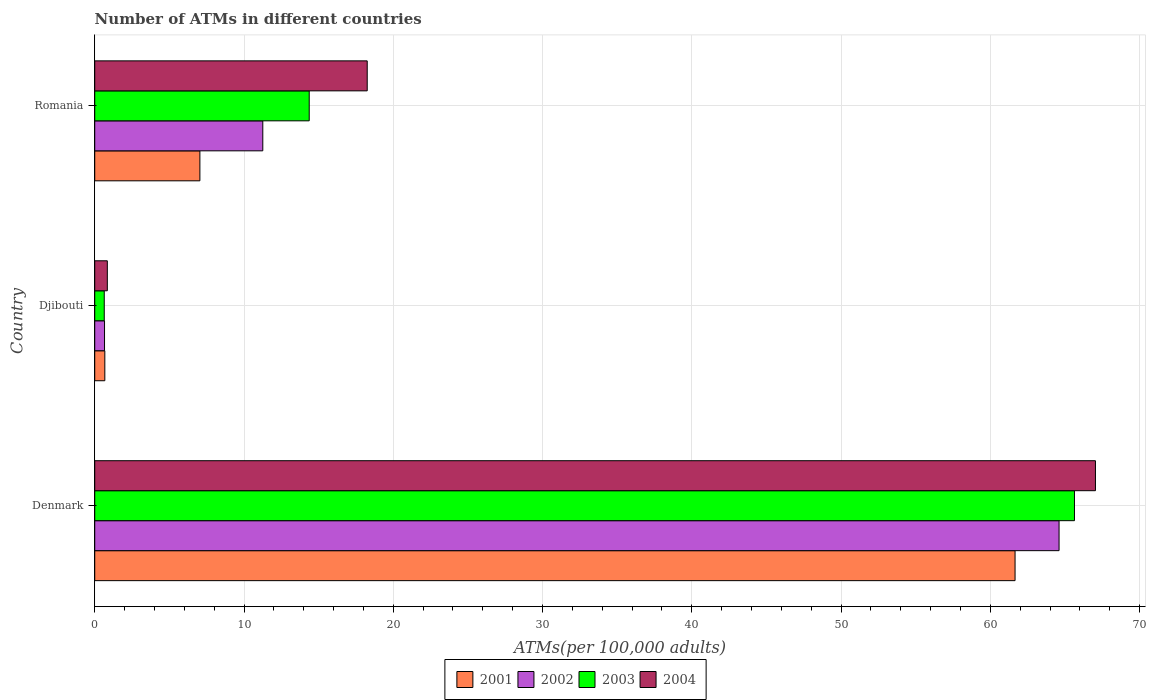How many bars are there on the 3rd tick from the top?
Your answer should be compact. 4. How many bars are there on the 3rd tick from the bottom?
Your response must be concise. 4. What is the label of the 3rd group of bars from the top?
Provide a short and direct response. Denmark. In how many cases, is the number of bars for a given country not equal to the number of legend labels?
Ensure brevity in your answer.  0. What is the number of ATMs in 2001 in Romania?
Your response must be concise. 7.04. Across all countries, what is the maximum number of ATMs in 2004?
Provide a succinct answer. 67.04. Across all countries, what is the minimum number of ATMs in 2001?
Provide a succinct answer. 0.68. In which country was the number of ATMs in 2002 maximum?
Your answer should be very brief. Denmark. In which country was the number of ATMs in 2002 minimum?
Keep it short and to the point. Djibouti. What is the total number of ATMs in 2003 in the graph?
Provide a short and direct response. 80.65. What is the difference between the number of ATMs in 2004 in Denmark and that in Romania?
Give a very brief answer. 48.79. What is the difference between the number of ATMs in 2003 in Denmark and the number of ATMs in 2001 in Djibouti?
Your answer should be very brief. 64.96. What is the average number of ATMs in 2003 per country?
Your answer should be very brief. 26.88. What is the difference between the number of ATMs in 2002 and number of ATMs in 2001 in Romania?
Provide a succinct answer. 4.21. What is the ratio of the number of ATMs in 2003 in Denmark to that in Djibouti?
Ensure brevity in your answer.  102.88. Is the number of ATMs in 2002 in Denmark less than that in Romania?
Your answer should be compact. No. What is the difference between the highest and the second highest number of ATMs in 2003?
Offer a very short reply. 51.27. What is the difference between the highest and the lowest number of ATMs in 2001?
Your response must be concise. 60.98. In how many countries, is the number of ATMs in 2004 greater than the average number of ATMs in 2004 taken over all countries?
Make the answer very short. 1. Is it the case that in every country, the sum of the number of ATMs in 2004 and number of ATMs in 2003 is greater than the sum of number of ATMs in 2002 and number of ATMs in 2001?
Keep it short and to the point. No. What does the 4th bar from the bottom in Denmark represents?
Give a very brief answer. 2004. Are all the bars in the graph horizontal?
Your answer should be compact. Yes. Does the graph contain grids?
Offer a terse response. Yes. Where does the legend appear in the graph?
Your answer should be compact. Bottom center. How many legend labels are there?
Give a very brief answer. 4. What is the title of the graph?
Offer a very short reply. Number of ATMs in different countries. What is the label or title of the X-axis?
Ensure brevity in your answer.  ATMs(per 100,0 adults). What is the ATMs(per 100,000 adults) of 2001 in Denmark?
Make the answer very short. 61.66. What is the ATMs(per 100,000 adults) of 2002 in Denmark?
Offer a very short reply. 64.61. What is the ATMs(per 100,000 adults) of 2003 in Denmark?
Make the answer very short. 65.64. What is the ATMs(per 100,000 adults) of 2004 in Denmark?
Make the answer very short. 67.04. What is the ATMs(per 100,000 adults) of 2001 in Djibouti?
Ensure brevity in your answer.  0.68. What is the ATMs(per 100,000 adults) in 2002 in Djibouti?
Keep it short and to the point. 0.66. What is the ATMs(per 100,000 adults) in 2003 in Djibouti?
Your answer should be compact. 0.64. What is the ATMs(per 100,000 adults) in 2004 in Djibouti?
Your answer should be very brief. 0.84. What is the ATMs(per 100,000 adults) of 2001 in Romania?
Provide a succinct answer. 7.04. What is the ATMs(per 100,000 adults) in 2002 in Romania?
Give a very brief answer. 11.26. What is the ATMs(per 100,000 adults) of 2003 in Romania?
Offer a very short reply. 14.37. What is the ATMs(per 100,000 adults) in 2004 in Romania?
Provide a short and direct response. 18.26. Across all countries, what is the maximum ATMs(per 100,000 adults) in 2001?
Offer a terse response. 61.66. Across all countries, what is the maximum ATMs(per 100,000 adults) of 2002?
Provide a succinct answer. 64.61. Across all countries, what is the maximum ATMs(per 100,000 adults) of 2003?
Keep it short and to the point. 65.64. Across all countries, what is the maximum ATMs(per 100,000 adults) in 2004?
Provide a succinct answer. 67.04. Across all countries, what is the minimum ATMs(per 100,000 adults) in 2001?
Make the answer very short. 0.68. Across all countries, what is the minimum ATMs(per 100,000 adults) of 2002?
Your answer should be very brief. 0.66. Across all countries, what is the minimum ATMs(per 100,000 adults) in 2003?
Provide a succinct answer. 0.64. Across all countries, what is the minimum ATMs(per 100,000 adults) in 2004?
Your answer should be compact. 0.84. What is the total ATMs(per 100,000 adults) of 2001 in the graph?
Your answer should be very brief. 69.38. What is the total ATMs(per 100,000 adults) in 2002 in the graph?
Make the answer very short. 76.52. What is the total ATMs(per 100,000 adults) in 2003 in the graph?
Your answer should be compact. 80.65. What is the total ATMs(per 100,000 adults) in 2004 in the graph?
Keep it short and to the point. 86.14. What is the difference between the ATMs(per 100,000 adults) in 2001 in Denmark and that in Djibouti?
Make the answer very short. 60.98. What is the difference between the ATMs(per 100,000 adults) in 2002 in Denmark and that in Djibouti?
Offer a terse response. 63.95. What is the difference between the ATMs(per 100,000 adults) in 2003 in Denmark and that in Djibouti?
Your answer should be compact. 65. What is the difference between the ATMs(per 100,000 adults) of 2004 in Denmark and that in Djibouti?
Provide a succinct answer. 66.2. What is the difference between the ATMs(per 100,000 adults) of 2001 in Denmark and that in Romania?
Ensure brevity in your answer.  54.61. What is the difference between the ATMs(per 100,000 adults) in 2002 in Denmark and that in Romania?
Your answer should be very brief. 53.35. What is the difference between the ATMs(per 100,000 adults) of 2003 in Denmark and that in Romania?
Provide a succinct answer. 51.27. What is the difference between the ATMs(per 100,000 adults) in 2004 in Denmark and that in Romania?
Ensure brevity in your answer.  48.79. What is the difference between the ATMs(per 100,000 adults) in 2001 in Djibouti and that in Romania?
Ensure brevity in your answer.  -6.37. What is the difference between the ATMs(per 100,000 adults) in 2002 in Djibouti and that in Romania?
Your response must be concise. -10.6. What is the difference between the ATMs(per 100,000 adults) of 2003 in Djibouti and that in Romania?
Offer a very short reply. -13.73. What is the difference between the ATMs(per 100,000 adults) of 2004 in Djibouti and that in Romania?
Keep it short and to the point. -17.41. What is the difference between the ATMs(per 100,000 adults) of 2001 in Denmark and the ATMs(per 100,000 adults) of 2002 in Djibouti?
Ensure brevity in your answer.  61. What is the difference between the ATMs(per 100,000 adults) in 2001 in Denmark and the ATMs(per 100,000 adults) in 2003 in Djibouti?
Provide a succinct answer. 61.02. What is the difference between the ATMs(per 100,000 adults) in 2001 in Denmark and the ATMs(per 100,000 adults) in 2004 in Djibouti?
Offer a terse response. 60.81. What is the difference between the ATMs(per 100,000 adults) of 2002 in Denmark and the ATMs(per 100,000 adults) of 2003 in Djibouti?
Make the answer very short. 63.97. What is the difference between the ATMs(per 100,000 adults) of 2002 in Denmark and the ATMs(per 100,000 adults) of 2004 in Djibouti?
Your response must be concise. 63.76. What is the difference between the ATMs(per 100,000 adults) in 2003 in Denmark and the ATMs(per 100,000 adults) in 2004 in Djibouti?
Ensure brevity in your answer.  64.79. What is the difference between the ATMs(per 100,000 adults) in 2001 in Denmark and the ATMs(per 100,000 adults) in 2002 in Romania?
Your response must be concise. 50.4. What is the difference between the ATMs(per 100,000 adults) in 2001 in Denmark and the ATMs(per 100,000 adults) in 2003 in Romania?
Provide a short and direct response. 47.29. What is the difference between the ATMs(per 100,000 adults) in 2001 in Denmark and the ATMs(per 100,000 adults) in 2004 in Romania?
Ensure brevity in your answer.  43.4. What is the difference between the ATMs(per 100,000 adults) of 2002 in Denmark and the ATMs(per 100,000 adults) of 2003 in Romania?
Offer a terse response. 50.24. What is the difference between the ATMs(per 100,000 adults) in 2002 in Denmark and the ATMs(per 100,000 adults) in 2004 in Romania?
Keep it short and to the point. 46.35. What is the difference between the ATMs(per 100,000 adults) in 2003 in Denmark and the ATMs(per 100,000 adults) in 2004 in Romania?
Your response must be concise. 47.38. What is the difference between the ATMs(per 100,000 adults) of 2001 in Djibouti and the ATMs(per 100,000 adults) of 2002 in Romania?
Your answer should be very brief. -10.58. What is the difference between the ATMs(per 100,000 adults) in 2001 in Djibouti and the ATMs(per 100,000 adults) in 2003 in Romania?
Your answer should be very brief. -13.69. What is the difference between the ATMs(per 100,000 adults) of 2001 in Djibouti and the ATMs(per 100,000 adults) of 2004 in Romania?
Your response must be concise. -17.58. What is the difference between the ATMs(per 100,000 adults) in 2002 in Djibouti and the ATMs(per 100,000 adults) in 2003 in Romania?
Provide a succinct answer. -13.71. What is the difference between the ATMs(per 100,000 adults) of 2002 in Djibouti and the ATMs(per 100,000 adults) of 2004 in Romania?
Your answer should be very brief. -17.6. What is the difference between the ATMs(per 100,000 adults) in 2003 in Djibouti and the ATMs(per 100,000 adults) in 2004 in Romania?
Offer a very short reply. -17.62. What is the average ATMs(per 100,000 adults) in 2001 per country?
Your response must be concise. 23.13. What is the average ATMs(per 100,000 adults) of 2002 per country?
Offer a very short reply. 25.51. What is the average ATMs(per 100,000 adults) of 2003 per country?
Offer a very short reply. 26.88. What is the average ATMs(per 100,000 adults) of 2004 per country?
Your response must be concise. 28.71. What is the difference between the ATMs(per 100,000 adults) of 2001 and ATMs(per 100,000 adults) of 2002 in Denmark?
Your response must be concise. -2.95. What is the difference between the ATMs(per 100,000 adults) of 2001 and ATMs(per 100,000 adults) of 2003 in Denmark?
Your response must be concise. -3.98. What is the difference between the ATMs(per 100,000 adults) of 2001 and ATMs(per 100,000 adults) of 2004 in Denmark?
Offer a terse response. -5.39. What is the difference between the ATMs(per 100,000 adults) in 2002 and ATMs(per 100,000 adults) in 2003 in Denmark?
Give a very brief answer. -1.03. What is the difference between the ATMs(per 100,000 adults) in 2002 and ATMs(per 100,000 adults) in 2004 in Denmark?
Give a very brief answer. -2.44. What is the difference between the ATMs(per 100,000 adults) in 2003 and ATMs(per 100,000 adults) in 2004 in Denmark?
Your answer should be very brief. -1.41. What is the difference between the ATMs(per 100,000 adults) of 2001 and ATMs(per 100,000 adults) of 2002 in Djibouti?
Your answer should be compact. 0.02. What is the difference between the ATMs(per 100,000 adults) in 2001 and ATMs(per 100,000 adults) in 2003 in Djibouti?
Ensure brevity in your answer.  0.04. What is the difference between the ATMs(per 100,000 adults) of 2001 and ATMs(per 100,000 adults) of 2004 in Djibouti?
Provide a succinct answer. -0.17. What is the difference between the ATMs(per 100,000 adults) of 2002 and ATMs(per 100,000 adults) of 2003 in Djibouti?
Keep it short and to the point. 0.02. What is the difference between the ATMs(per 100,000 adults) of 2002 and ATMs(per 100,000 adults) of 2004 in Djibouti?
Make the answer very short. -0.19. What is the difference between the ATMs(per 100,000 adults) of 2003 and ATMs(per 100,000 adults) of 2004 in Djibouti?
Offer a very short reply. -0.21. What is the difference between the ATMs(per 100,000 adults) of 2001 and ATMs(per 100,000 adults) of 2002 in Romania?
Provide a short and direct response. -4.21. What is the difference between the ATMs(per 100,000 adults) of 2001 and ATMs(per 100,000 adults) of 2003 in Romania?
Ensure brevity in your answer.  -7.32. What is the difference between the ATMs(per 100,000 adults) of 2001 and ATMs(per 100,000 adults) of 2004 in Romania?
Provide a succinct answer. -11.21. What is the difference between the ATMs(per 100,000 adults) of 2002 and ATMs(per 100,000 adults) of 2003 in Romania?
Your answer should be very brief. -3.11. What is the difference between the ATMs(per 100,000 adults) in 2002 and ATMs(per 100,000 adults) in 2004 in Romania?
Your answer should be compact. -7. What is the difference between the ATMs(per 100,000 adults) of 2003 and ATMs(per 100,000 adults) of 2004 in Romania?
Keep it short and to the point. -3.89. What is the ratio of the ATMs(per 100,000 adults) in 2001 in Denmark to that in Djibouti?
Give a very brief answer. 91.18. What is the ratio of the ATMs(per 100,000 adults) of 2002 in Denmark to that in Djibouti?
Make the answer very short. 98.45. What is the ratio of the ATMs(per 100,000 adults) in 2003 in Denmark to that in Djibouti?
Keep it short and to the point. 102.88. What is the ratio of the ATMs(per 100,000 adults) of 2004 in Denmark to that in Djibouti?
Ensure brevity in your answer.  79.46. What is the ratio of the ATMs(per 100,000 adults) of 2001 in Denmark to that in Romania?
Give a very brief answer. 8.75. What is the ratio of the ATMs(per 100,000 adults) in 2002 in Denmark to that in Romania?
Give a very brief answer. 5.74. What is the ratio of the ATMs(per 100,000 adults) in 2003 in Denmark to that in Romania?
Your response must be concise. 4.57. What is the ratio of the ATMs(per 100,000 adults) in 2004 in Denmark to that in Romania?
Give a very brief answer. 3.67. What is the ratio of the ATMs(per 100,000 adults) in 2001 in Djibouti to that in Romania?
Keep it short and to the point. 0.1. What is the ratio of the ATMs(per 100,000 adults) of 2002 in Djibouti to that in Romania?
Give a very brief answer. 0.06. What is the ratio of the ATMs(per 100,000 adults) in 2003 in Djibouti to that in Romania?
Offer a very short reply. 0.04. What is the ratio of the ATMs(per 100,000 adults) of 2004 in Djibouti to that in Romania?
Your response must be concise. 0.05. What is the difference between the highest and the second highest ATMs(per 100,000 adults) of 2001?
Offer a terse response. 54.61. What is the difference between the highest and the second highest ATMs(per 100,000 adults) in 2002?
Your response must be concise. 53.35. What is the difference between the highest and the second highest ATMs(per 100,000 adults) in 2003?
Your response must be concise. 51.27. What is the difference between the highest and the second highest ATMs(per 100,000 adults) in 2004?
Your answer should be compact. 48.79. What is the difference between the highest and the lowest ATMs(per 100,000 adults) of 2001?
Offer a very short reply. 60.98. What is the difference between the highest and the lowest ATMs(per 100,000 adults) of 2002?
Ensure brevity in your answer.  63.95. What is the difference between the highest and the lowest ATMs(per 100,000 adults) of 2003?
Make the answer very short. 65. What is the difference between the highest and the lowest ATMs(per 100,000 adults) in 2004?
Provide a succinct answer. 66.2. 